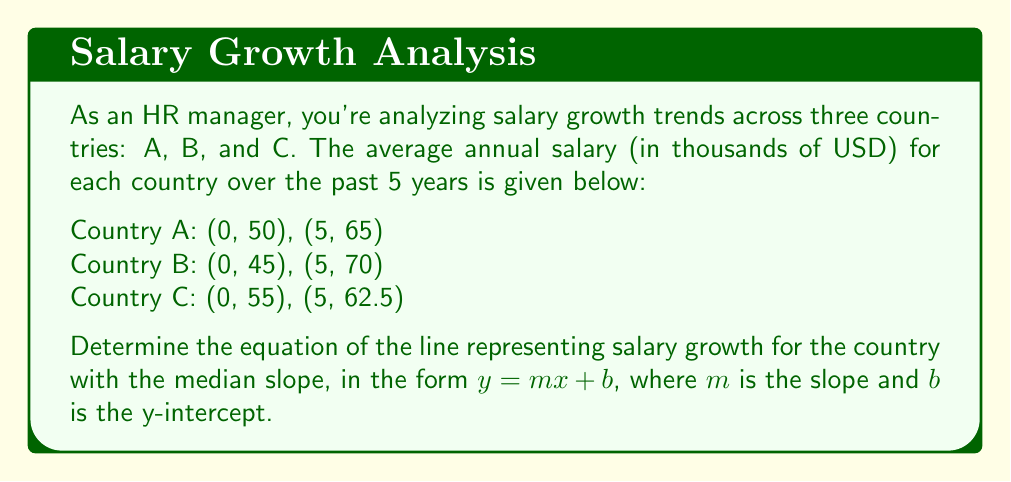Solve this math problem. To solve this problem, we need to follow these steps:

1. Calculate the slope for each country's salary growth line.
2. Identify the country with the median slope.
3. Use the point-slope form to determine the equation of the line for that country.
4. Convert the equation to slope-intercept form.

Step 1: Calculate slopes

For each country, we can calculate the slope using the formula:
$m = \frac{y_2 - y_1}{x_2 - x_1}$

Country A: $m_A = \frac{65 - 50}{5 - 0} = \frac{15}{5} = 3$

Country B: $m_B = \frac{70 - 45}{5 - 0} = \frac{25}{5} = 5$

Country C: $m_C = \frac{62.5 - 55}{5 - 0} = \frac{7.5}{5} = 1.5$

Step 2: Identify median slope

Arranging the slopes in ascending order: 1.5, 3, 5
The median slope is 3, which corresponds to Country A.

Step 3: Use point-slope form

We'll use the point (0, 50) from Country A's data.
Point-slope form: $y - y_1 = m(x - x_1)$
$y - 50 = 3(x - 0)$

Step 4: Convert to slope-intercept form

$y - 50 = 3x$
$y = 3x + 50$

Therefore, the equation of the line representing salary growth for the country with the median slope is $y = 3x + 50$.
Answer: $y = 3x + 50$ 